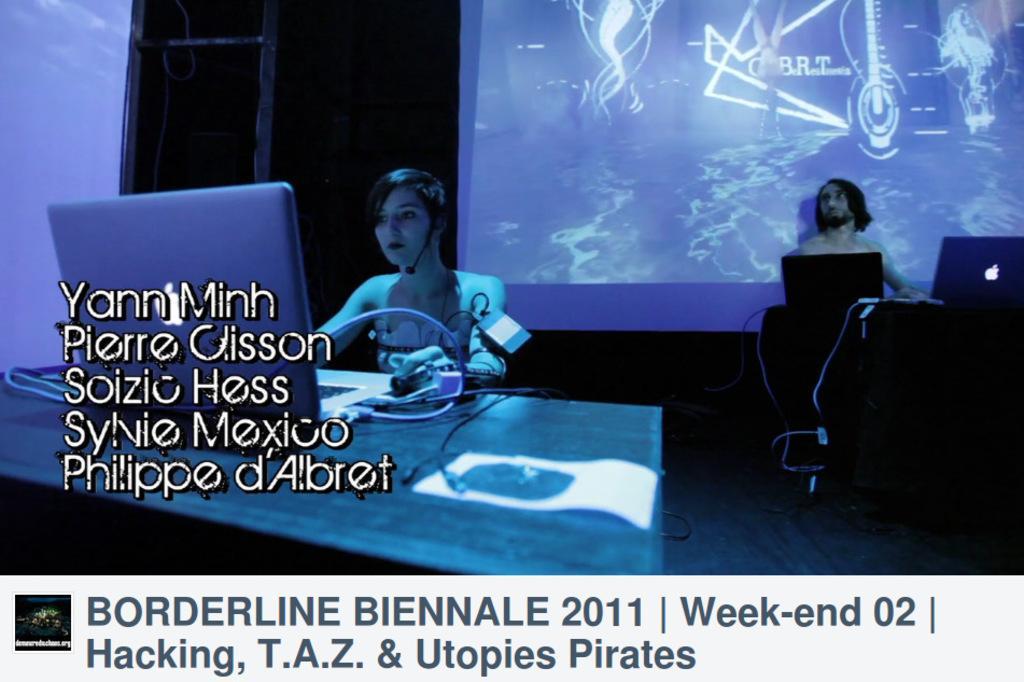How would you summarize this image in a sentence or two? In the image we can see an animated picture. In it we can see a girl and a boy sitting. Here we can see electronic devices, cable wire, projected screen and the text. 